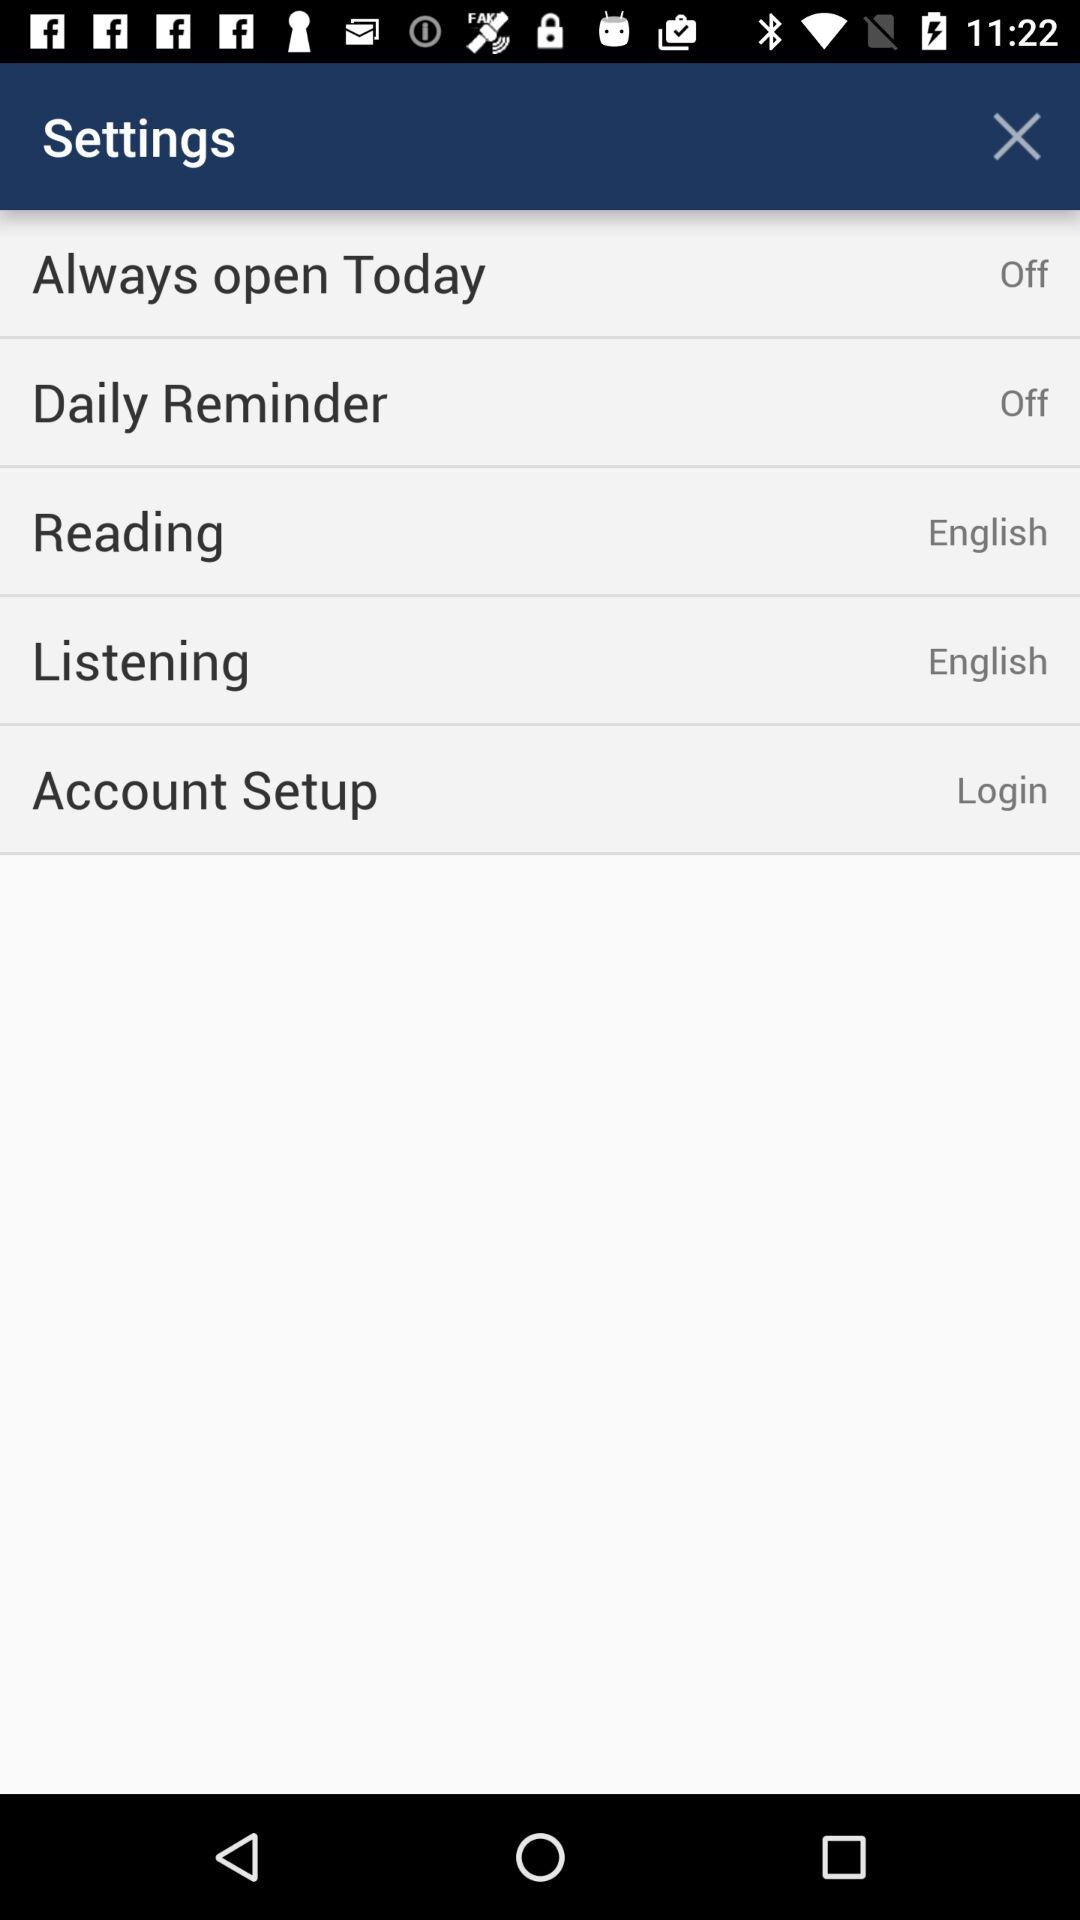What is the status of "Daily Reminder"? The status of "Daily Reminder" is "off". 